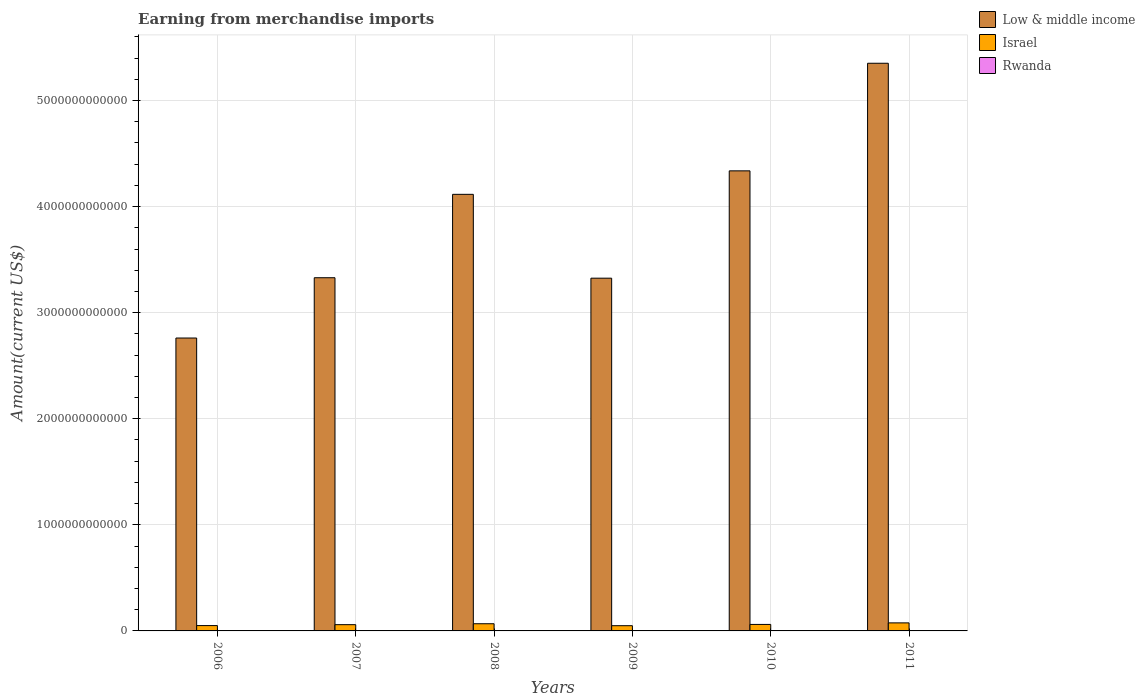How many different coloured bars are there?
Offer a very short reply. 3. How many groups of bars are there?
Ensure brevity in your answer.  6. Are the number of bars on each tick of the X-axis equal?
Offer a terse response. Yes. How many bars are there on the 2nd tick from the left?
Give a very brief answer. 3. What is the label of the 6th group of bars from the left?
Give a very brief answer. 2011. In how many cases, is the number of bars for a given year not equal to the number of legend labels?
Ensure brevity in your answer.  0. What is the amount earned from merchandise imports in Low & middle income in 2009?
Offer a terse response. 3.33e+12. Across all years, what is the maximum amount earned from merchandise imports in Low & middle income?
Your answer should be very brief. 5.35e+12. Across all years, what is the minimum amount earned from merchandise imports in Low & middle income?
Keep it short and to the point. 2.76e+12. In which year was the amount earned from merchandise imports in Rwanda minimum?
Make the answer very short. 2006. What is the total amount earned from merchandise imports in Low & middle income in the graph?
Your response must be concise. 2.32e+13. What is the difference between the amount earned from merchandise imports in Israel in 2006 and that in 2010?
Your answer should be compact. -1.09e+1. What is the difference between the amount earned from merchandise imports in Rwanda in 2008 and the amount earned from merchandise imports in Low & middle income in 2010?
Provide a succinct answer. -4.34e+12. What is the average amount earned from merchandise imports in Low & middle income per year?
Keep it short and to the point. 3.87e+12. In the year 2006, what is the difference between the amount earned from merchandise imports in Low & middle income and amount earned from merchandise imports in Israel?
Keep it short and to the point. 2.71e+12. In how many years, is the amount earned from merchandise imports in Israel greater than 5400000000000 US$?
Your answer should be compact. 0. What is the ratio of the amount earned from merchandise imports in Rwanda in 2008 to that in 2010?
Keep it short and to the point. 0.82. Is the amount earned from merchandise imports in Low & middle income in 2006 less than that in 2008?
Your answer should be compact. Yes. What is the difference between the highest and the second highest amount earned from merchandise imports in Israel?
Your answer should be compact. 8.17e+09. What is the difference between the highest and the lowest amount earned from merchandise imports in Israel?
Your answer should be very brief. 2.66e+1. What does the 1st bar from the right in 2006 represents?
Your answer should be compact. Rwanda. Is it the case that in every year, the sum of the amount earned from merchandise imports in Low & middle income and amount earned from merchandise imports in Israel is greater than the amount earned from merchandise imports in Rwanda?
Offer a very short reply. Yes. How many years are there in the graph?
Offer a very short reply. 6. What is the difference between two consecutive major ticks on the Y-axis?
Your answer should be very brief. 1.00e+12. Does the graph contain any zero values?
Keep it short and to the point. No. Does the graph contain grids?
Give a very brief answer. Yes. How many legend labels are there?
Make the answer very short. 3. What is the title of the graph?
Offer a very short reply. Earning from merchandise imports. What is the label or title of the Y-axis?
Provide a succinct answer. Amount(current US$). What is the Amount(current US$) of Low & middle income in 2006?
Give a very brief answer. 2.76e+12. What is the Amount(current US$) of Israel in 2006?
Your answer should be compact. 5.03e+1. What is the Amount(current US$) of Rwanda in 2006?
Your answer should be very brief. 5.91e+08. What is the Amount(current US$) of Low & middle income in 2007?
Make the answer very short. 3.33e+12. What is the Amount(current US$) in Israel in 2007?
Give a very brief answer. 5.90e+1. What is the Amount(current US$) in Rwanda in 2007?
Your response must be concise. 7.71e+08. What is the Amount(current US$) in Low & middle income in 2008?
Offer a very short reply. 4.12e+12. What is the Amount(current US$) in Israel in 2008?
Your answer should be compact. 6.77e+1. What is the Amount(current US$) of Rwanda in 2008?
Provide a short and direct response. 1.17e+09. What is the Amount(current US$) of Low & middle income in 2009?
Offer a very short reply. 3.33e+12. What is the Amount(current US$) in Israel in 2009?
Provide a short and direct response. 4.93e+1. What is the Amount(current US$) of Rwanda in 2009?
Your answer should be compact. 1.31e+09. What is the Amount(current US$) of Low & middle income in 2010?
Your response must be concise. 4.34e+12. What is the Amount(current US$) in Israel in 2010?
Offer a very short reply. 6.12e+1. What is the Amount(current US$) in Rwanda in 2010?
Provide a succinct answer. 1.43e+09. What is the Amount(current US$) of Low & middle income in 2011?
Make the answer very short. 5.35e+12. What is the Amount(current US$) of Israel in 2011?
Provide a short and direct response. 7.58e+1. What is the Amount(current US$) of Rwanda in 2011?
Provide a short and direct response. 2.04e+09. Across all years, what is the maximum Amount(current US$) in Low & middle income?
Provide a succinct answer. 5.35e+12. Across all years, what is the maximum Amount(current US$) of Israel?
Offer a very short reply. 7.58e+1. Across all years, what is the maximum Amount(current US$) of Rwanda?
Your response must be concise. 2.04e+09. Across all years, what is the minimum Amount(current US$) of Low & middle income?
Give a very brief answer. 2.76e+12. Across all years, what is the minimum Amount(current US$) of Israel?
Make the answer very short. 4.93e+1. Across all years, what is the minimum Amount(current US$) of Rwanda?
Ensure brevity in your answer.  5.91e+08. What is the total Amount(current US$) in Low & middle income in the graph?
Make the answer very short. 2.32e+13. What is the total Amount(current US$) of Israel in the graph?
Your answer should be compact. 3.63e+11. What is the total Amount(current US$) in Rwanda in the graph?
Keep it short and to the point. 7.31e+09. What is the difference between the Amount(current US$) of Low & middle income in 2006 and that in 2007?
Your answer should be compact. -5.68e+11. What is the difference between the Amount(current US$) of Israel in 2006 and that in 2007?
Keep it short and to the point. -8.70e+09. What is the difference between the Amount(current US$) of Rwanda in 2006 and that in 2007?
Ensure brevity in your answer.  -1.79e+08. What is the difference between the Amount(current US$) in Low & middle income in 2006 and that in 2008?
Give a very brief answer. -1.35e+12. What is the difference between the Amount(current US$) of Israel in 2006 and that in 2008?
Your answer should be compact. -1.73e+1. What is the difference between the Amount(current US$) in Rwanda in 2006 and that in 2008?
Offer a terse response. -5.83e+08. What is the difference between the Amount(current US$) of Low & middle income in 2006 and that in 2009?
Keep it short and to the point. -5.64e+11. What is the difference between the Amount(current US$) of Israel in 2006 and that in 2009?
Ensure brevity in your answer.  1.06e+09. What is the difference between the Amount(current US$) in Rwanda in 2006 and that in 2009?
Make the answer very short. -7.17e+08. What is the difference between the Amount(current US$) in Low & middle income in 2006 and that in 2010?
Your response must be concise. -1.58e+12. What is the difference between the Amount(current US$) of Israel in 2006 and that in 2010?
Keep it short and to the point. -1.09e+1. What is the difference between the Amount(current US$) in Rwanda in 2006 and that in 2010?
Keep it short and to the point. -8.40e+08. What is the difference between the Amount(current US$) of Low & middle income in 2006 and that in 2011?
Your answer should be compact. -2.59e+12. What is the difference between the Amount(current US$) of Israel in 2006 and that in 2011?
Ensure brevity in your answer.  -2.55e+1. What is the difference between the Amount(current US$) of Rwanda in 2006 and that in 2011?
Offer a terse response. -1.45e+09. What is the difference between the Amount(current US$) in Low & middle income in 2007 and that in 2008?
Keep it short and to the point. -7.86e+11. What is the difference between the Amount(current US$) of Israel in 2007 and that in 2008?
Offer a very short reply. -8.62e+09. What is the difference between the Amount(current US$) in Rwanda in 2007 and that in 2008?
Your answer should be compact. -4.03e+08. What is the difference between the Amount(current US$) of Low & middle income in 2007 and that in 2009?
Ensure brevity in your answer.  4.29e+09. What is the difference between the Amount(current US$) in Israel in 2007 and that in 2009?
Provide a succinct answer. 9.76e+09. What is the difference between the Amount(current US$) in Rwanda in 2007 and that in 2009?
Offer a terse response. -5.38e+08. What is the difference between the Amount(current US$) in Low & middle income in 2007 and that in 2010?
Your response must be concise. -1.01e+12. What is the difference between the Amount(current US$) of Israel in 2007 and that in 2010?
Your answer should be compact. -2.17e+09. What is the difference between the Amount(current US$) in Rwanda in 2007 and that in 2010?
Offer a terse response. -6.60e+08. What is the difference between the Amount(current US$) in Low & middle income in 2007 and that in 2011?
Make the answer very short. -2.02e+12. What is the difference between the Amount(current US$) in Israel in 2007 and that in 2011?
Provide a short and direct response. -1.68e+1. What is the difference between the Amount(current US$) of Rwanda in 2007 and that in 2011?
Your response must be concise. -1.27e+09. What is the difference between the Amount(current US$) of Low & middle income in 2008 and that in 2009?
Provide a short and direct response. 7.90e+11. What is the difference between the Amount(current US$) of Israel in 2008 and that in 2009?
Ensure brevity in your answer.  1.84e+1. What is the difference between the Amount(current US$) of Rwanda in 2008 and that in 2009?
Offer a terse response. -1.34e+08. What is the difference between the Amount(current US$) in Low & middle income in 2008 and that in 2010?
Make the answer very short. -2.21e+11. What is the difference between the Amount(current US$) of Israel in 2008 and that in 2010?
Keep it short and to the point. 6.45e+09. What is the difference between the Amount(current US$) of Rwanda in 2008 and that in 2010?
Keep it short and to the point. -2.57e+08. What is the difference between the Amount(current US$) of Low & middle income in 2008 and that in 2011?
Keep it short and to the point. -1.24e+12. What is the difference between the Amount(current US$) in Israel in 2008 and that in 2011?
Give a very brief answer. -8.17e+09. What is the difference between the Amount(current US$) of Rwanda in 2008 and that in 2011?
Keep it short and to the point. -8.65e+08. What is the difference between the Amount(current US$) in Low & middle income in 2009 and that in 2010?
Your answer should be compact. -1.01e+12. What is the difference between the Amount(current US$) in Israel in 2009 and that in 2010?
Provide a short and direct response. -1.19e+1. What is the difference between the Amount(current US$) of Rwanda in 2009 and that in 2010?
Ensure brevity in your answer.  -1.23e+08. What is the difference between the Amount(current US$) of Low & middle income in 2009 and that in 2011?
Give a very brief answer. -2.03e+12. What is the difference between the Amount(current US$) in Israel in 2009 and that in 2011?
Your answer should be compact. -2.66e+1. What is the difference between the Amount(current US$) in Rwanda in 2009 and that in 2011?
Your response must be concise. -7.31e+08. What is the difference between the Amount(current US$) of Low & middle income in 2010 and that in 2011?
Ensure brevity in your answer.  -1.01e+12. What is the difference between the Amount(current US$) in Israel in 2010 and that in 2011?
Provide a short and direct response. -1.46e+1. What is the difference between the Amount(current US$) of Rwanda in 2010 and that in 2011?
Your response must be concise. -6.08e+08. What is the difference between the Amount(current US$) of Low & middle income in 2006 and the Amount(current US$) of Israel in 2007?
Offer a terse response. 2.70e+12. What is the difference between the Amount(current US$) of Low & middle income in 2006 and the Amount(current US$) of Rwanda in 2007?
Offer a very short reply. 2.76e+12. What is the difference between the Amount(current US$) in Israel in 2006 and the Amount(current US$) in Rwanda in 2007?
Keep it short and to the point. 4.96e+1. What is the difference between the Amount(current US$) in Low & middle income in 2006 and the Amount(current US$) in Israel in 2008?
Give a very brief answer. 2.69e+12. What is the difference between the Amount(current US$) of Low & middle income in 2006 and the Amount(current US$) of Rwanda in 2008?
Offer a terse response. 2.76e+12. What is the difference between the Amount(current US$) of Israel in 2006 and the Amount(current US$) of Rwanda in 2008?
Give a very brief answer. 4.92e+1. What is the difference between the Amount(current US$) in Low & middle income in 2006 and the Amount(current US$) in Israel in 2009?
Make the answer very short. 2.71e+12. What is the difference between the Amount(current US$) in Low & middle income in 2006 and the Amount(current US$) in Rwanda in 2009?
Your answer should be compact. 2.76e+12. What is the difference between the Amount(current US$) in Israel in 2006 and the Amount(current US$) in Rwanda in 2009?
Make the answer very short. 4.90e+1. What is the difference between the Amount(current US$) in Low & middle income in 2006 and the Amount(current US$) in Israel in 2010?
Offer a very short reply. 2.70e+12. What is the difference between the Amount(current US$) in Low & middle income in 2006 and the Amount(current US$) in Rwanda in 2010?
Provide a short and direct response. 2.76e+12. What is the difference between the Amount(current US$) of Israel in 2006 and the Amount(current US$) of Rwanda in 2010?
Offer a terse response. 4.89e+1. What is the difference between the Amount(current US$) of Low & middle income in 2006 and the Amount(current US$) of Israel in 2011?
Your response must be concise. 2.69e+12. What is the difference between the Amount(current US$) in Low & middle income in 2006 and the Amount(current US$) in Rwanda in 2011?
Provide a succinct answer. 2.76e+12. What is the difference between the Amount(current US$) of Israel in 2006 and the Amount(current US$) of Rwanda in 2011?
Your response must be concise. 4.83e+1. What is the difference between the Amount(current US$) in Low & middle income in 2007 and the Amount(current US$) in Israel in 2008?
Offer a terse response. 3.26e+12. What is the difference between the Amount(current US$) of Low & middle income in 2007 and the Amount(current US$) of Rwanda in 2008?
Your response must be concise. 3.33e+12. What is the difference between the Amount(current US$) of Israel in 2007 and the Amount(current US$) of Rwanda in 2008?
Your answer should be very brief. 5.79e+1. What is the difference between the Amount(current US$) in Low & middle income in 2007 and the Amount(current US$) in Israel in 2009?
Give a very brief answer. 3.28e+12. What is the difference between the Amount(current US$) of Low & middle income in 2007 and the Amount(current US$) of Rwanda in 2009?
Ensure brevity in your answer.  3.33e+12. What is the difference between the Amount(current US$) of Israel in 2007 and the Amount(current US$) of Rwanda in 2009?
Keep it short and to the point. 5.77e+1. What is the difference between the Amount(current US$) of Low & middle income in 2007 and the Amount(current US$) of Israel in 2010?
Provide a succinct answer. 3.27e+12. What is the difference between the Amount(current US$) in Low & middle income in 2007 and the Amount(current US$) in Rwanda in 2010?
Ensure brevity in your answer.  3.33e+12. What is the difference between the Amount(current US$) of Israel in 2007 and the Amount(current US$) of Rwanda in 2010?
Your answer should be compact. 5.76e+1. What is the difference between the Amount(current US$) in Low & middle income in 2007 and the Amount(current US$) in Israel in 2011?
Provide a succinct answer. 3.25e+12. What is the difference between the Amount(current US$) of Low & middle income in 2007 and the Amount(current US$) of Rwanda in 2011?
Offer a very short reply. 3.33e+12. What is the difference between the Amount(current US$) in Israel in 2007 and the Amount(current US$) in Rwanda in 2011?
Your answer should be compact. 5.70e+1. What is the difference between the Amount(current US$) in Low & middle income in 2008 and the Amount(current US$) in Israel in 2009?
Your answer should be very brief. 4.07e+12. What is the difference between the Amount(current US$) of Low & middle income in 2008 and the Amount(current US$) of Rwanda in 2009?
Your answer should be compact. 4.11e+12. What is the difference between the Amount(current US$) of Israel in 2008 and the Amount(current US$) of Rwanda in 2009?
Offer a terse response. 6.63e+1. What is the difference between the Amount(current US$) of Low & middle income in 2008 and the Amount(current US$) of Israel in 2010?
Give a very brief answer. 4.05e+12. What is the difference between the Amount(current US$) of Low & middle income in 2008 and the Amount(current US$) of Rwanda in 2010?
Provide a short and direct response. 4.11e+12. What is the difference between the Amount(current US$) in Israel in 2008 and the Amount(current US$) in Rwanda in 2010?
Ensure brevity in your answer.  6.62e+1. What is the difference between the Amount(current US$) in Low & middle income in 2008 and the Amount(current US$) in Israel in 2011?
Your answer should be very brief. 4.04e+12. What is the difference between the Amount(current US$) of Low & middle income in 2008 and the Amount(current US$) of Rwanda in 2011?
Your answer should be very brief. 4.11e+12. What is the difference between the Amount(current US$) in Israel in 2008 and the Amount(current US$) in Rwanda in 2011?
Give a very brief answer. 6.56e+1. What is the difference between the Amount(current US$) of Low & middle income in 2009 and the Amount(current US$) of Israel in 2010?
Make the answer very short. 3.26e+12. What is the difference between the Amount(current US$) of Low & middle income in 2009 and the Amount(current US$) of Rwanda in 2010?
Your answer should be compact. 3.32e+12. What is the difference between the Amount(current US$) of Israel in 2009 and the Amount(current US$) of Rwanda in 2010?
Offer a terse response. 4.78e+1. What is the difference between the Amount(current US$) in Low & middle income in 2009 and the Amount(current US$) in Israel in 2011?
Offer a terse response. 3.25e+12. What is the difference between the Amount(current US$) in Low & middle income in 2009 and the Amount(current US$) in Rwanda in 2011?
Ensure brevity in your answer.  3.32e+12. What is the difference between the Amount(current US$) in Israel in 2009 and the Amount(current US$) in Rwanda in 2011?
Provide a short and direct response. 4.72e+1. What is the difference between the Amount(current US$) in Low & middle income in 2010 and the Amount(current US$) in Israel in 2011?
Provide a succinct answer. 4.26e+12. What is the difference between the Amount(current US$) in Low & middle income in 2010 and the Amount(current US$) in Rwanda in 2011?
Ensure brevity in your answer.  4.33e+12. What is the difference between the Amount(current US$) in Israel in 2010 and the Amount(current US$) in Rwanda in 2011?
Your answer should be very brief. 5.92e+1. What is the average Amount(current US$) in Low & middle income per year?
Your response must be concise. 3.87e+12. What is the average Amount(current US$) of Israel per year?
Provide a short and direct response. 6.06e+1. What is the average Amount(current US$) in Rwanda per year?
Your response must be concise. 1.22e+09. In the year 2006, what is the difference between the Amount(current US$) in Low & middle income and Amount(current US$) in Israel?
Provide a succinct answer. 2.71e+12. In the year 2006, what is the difference between the Amount(current US$) of Low & middle income and Amount(current US$) of Rwanda?
Offer a very short reply. 2.76e+12. In the year 2006, what is the difference between the Amount(current US$) of Israel and Amount(current US$) of Rwanda?
Offer a very short reply. 4.97e+1. In the year 2007, what is the difference between the Amount(current US$) in Low & middle income and Amount(current US$) in Israel?
Your answer should be compact. 3.27e+12. In the year 2007, what is the difference between the Amount(current US$) of Low & middle income and Amount(current US$) of Rwanda?
Your response must be concise. 3.33e+12. In the year 2007, what is the difference between the Amount(current US$) in Israel and Amount(current US$) in Rwanda?
Offer a terse response. 5.83e+1. In the year 2008, what is the difference between the Amount(current US$) of Low & middle income and Amount(current US$) of Israel?
Your response must be concise. 4.05e+12. In the year 2008, what is the difference between the Amount(current US$) of Low & middle income and Amount(current US$) of Rwanda?
Ensure brevity in your answer.  4.11e+12. In the year 2008, what is the difference between the Amount(current US$) in Israel and Amount(current US$) in Rwanda?
Your response must be concise. 6.65e+1. In the year 2009, what is the difference between the Amount(current US$) in Low & middle income and Amount(current US$) in Israel?
Make the answer very short. 3.28e+12. In the year 2009, what is the difference between the Amount(current US$) in Low & middle income and Amount(current US$) in Rwanda?
Your answer should be very brief. 3.32e+12. In the year 2009, what is the difference between the Amount(current US$) in Israel and Amount(current US$) in Rwanda?
Your answer should be very brief. 4.80e+1. In the year 2010, what is the difference between the Amount(current US$) in Low & middle income and Amount(current US$) in Israel?
Ensure brevity in your answer.  4.28e+12. In the year 2010, what is the difference between the Amount(current US$) of Low & middle income and Amount(current US$) of Rwanda?
Give a very brief answer. 4.34e+12. In the year 2010, what is the difference between the Amount(current US$) in Israel and Amount(current US$) in Rwanda?
Make the answer very short. 5.98e+1. In the year 2011, what is the difference between the Amount(current US$) of Low & middle income and Amount(current US$) of Israel?
Offer a very short reply. 5.28e+12. In the year 2011, what is the difference between the Amount(current US$) in Low & middle income and Amount(current US$) in Rwanda?
Your response must be concise. 5.35e+12. In the year 2011, what is the difference between the Amount(current US$) in Israel and Amount(current US$) in Rwanda?
Your answer should be compact. 7.38e+1. What is the ratio of the Amount(current US$) of Low & middle income in 2006 to that in 2007?
Provide a short and direct response. 0.83. What is the ratio of the Amount(current US$) in Israel in 2006 to that in 2007?
Provide a succinct answer. 0.85. What is the ratio of the Amount(current US$) in Rwanda in 2006 to that in 2007?
Offer a terse response. 0.77. What is the ratio of the Amount(current US$) in Low & middle income in 2006 to that in 2008?
Keep it short and to the point. 0.67. What is the ratio of the Amount(current US$) in Israel in 2006 to that in 2008?
Provide a short and direct response. 0.74. What is the ratio of the Amount(current US$) of Rwanda in 2006 to that in 2008?
Your answer should be compact. 0.5. What is the ratio of the Amount(current US$) in Low & middle income in 2006 to that in 2009?
Provide a short and direct response. 0.83. What is the ratio of the Amount(current US$) of Israel in 2006 to that in 2009?
Your answer should be very brief. 1.02. What is the ratio of the Amount(current US$) in Rwanda in 2006 to that in 2009?
Keep it short and to the point. 0.45. What is the ratio of the Amount(current US$) in Low & middle income in 2006 to that in 2010?
Offer a very short reply. 0.64. What is the ratio of the Amount(current US$) in Israel in 2006 to that in 2010?
Provide a short and direct response. 0.82. What is the ratio of the Amount(current US$) in Rwanda in 2006 to that in 2010?
Your answer should be very brief. 0.41. What is the ratio of the Amount(current US$) in Low & middle income in 2006 to that in 2011?
Make the answer very short. 0.52. What is the ratio of the Amount(current US$) in Israel in 2006 to that in 2011?
Provide a succinct answer. 0.66. What is the ratio of the Amount(current US$) of Rwanda in 2006 to that in 2011?
Give a very brief answer. 0.29. What is the ratio of the Amount(current US$) of Low & middle income in 2007 to that in 2008?
Provide a succinct answer. 0.81. What is the ratio of the Amount(current US$) in Israel in 2007 to that in 2008?
Ensure brevity in your answer.  0.87. What is the ratio of the Amount(current US$) of Rwanda in 2007 to that in 2008?
Ensure brevity in your answer.  0.66. What is the ratio of the Amount(current US$) in Israel in 2007 to that in 2009?
Your answer should be very brief. 1.2. What is the ratio of the Amount(current US$) of Rwanda in 2007 to that in 2009?
Provide a succinct answer. 0.59. What is the ratio of the Amount(current US$) of Low & middle income in 2007 to that in 2010?
Offer a terse response. 0.77. What is the ratio of the Amount(current US$) of Israel in 2007 to that in 2010?
Offer a very short reply. 0.96. What is the ratio of the Amount(current US$) in Rwanda in 2007 to that in 2010?
Your answer should be very brief. 0.54. What is the ratio of the Amount(current US$) in Low & middle income in 2007 to that in 2011?
Your answer should be very brief. 0.62. What is the ratio of the Amount(current US$) of Israel in 2007 to that in 2011?
Ensure brevity in your answer.  0.78. What is the ratio of the Amount(current US$) in Rwanda in 2007 to that in 2011?
Your response must be concise. 0.38. What is the ratio of the Amount(current US$) of Low & middle income in 2008 to that in 2009?
Provide a short and direct response. 1.24. What is the ratio of the Amount(current US$) of Israel in 2008 to that in 2009?
Provide a short and direct response. 1.37. What is the ratio of the Amount(current US$) of Rwanda in 2008 to that in 2009?
Give a very brief answer. 0.9. What is the ratio of the Amount(current US$) in Low & middle income in 2008 to that in 2010?
Offer a very short reply. 0.95. What is the ratio of the Amount(current US$) of Israel in 2008 to that in 2010?
Give a very brief answer. 1.11. What is the ratio of the Amount(current US$) of Rwanda in 2008 to that in 2010?
Offer a terse response. 0.82. What is the ratio of the Amount(current US$) of Low & middle income in 2008 to that in 2011?
Offer a terse response. 0.77. What is the ratio of the Amount(current US$) in Israel in 2008 to that in 2011?
Keep it short and to the point. 0.89. What is the ratio of the Amount(current US$) in Rwanda in 2008 to that in 2011?
Ensure brevity in your answer.  0.58. What is the ratio of the Amount(current US$) in Low & middle income in 2009 to that in 2010?
Provide a short and direct response. 0.77. What is the ratio of the Amount(current US$) in Israel in 2009 to that in 2010?
Offer a very short reply. 0.81. What is the ratio of the Amount(current US$) in Rwanda in 2009 to that in 2010?
Offer a terse response. 0.91. What is the ratio of the Amount(current US$) in Low & middle income in 2009 to that in 2011?
Your answer should be compact. 0.62. What is the ratio of the Amount(current US$) in Israel in 2009 to that in 2011?
Provide a succinct answer. 0.65. What is the ratio of the Amount(current US$) of Rwanda in 2009 to that in 2011?
Your answer should be compact. 0.64. What is the ratio of the Amount(current US$) in Low & middle income in 2010 to that in 2011?
Ensure brevity in your answer.  0.81. What is the ratio of the Amount(current US$) in Israel in 2010 to that in 2011?
Provide a succinct answer. 0.81. What is the ratio of the Amount(current US$) of Rwanda in 2010 to that in 2011?
Ensure brevity in your answer.  0.7. What is the difference between the highest and the second highest Amount(current US$) of Low & middle income?
Provide a short and direct response. 1.01e+12. What is the difference between the highest and the second highest Amount(current US$) in Israel?
Offer a terse response. 8.17e+09. What is the difference between the highest and the second highest Amount(current US$) of Rwanda?
Your response must be concise. 6.08e+08. What is the difference between the highest and the lowest Amount(current US$) of Low & middle income?
Keep it short and to the point. 2.59e+12. What is the difference between the highest and the lowest Amount(current US$) in Israel?
Keep it short and to the point. 2.66e+1. What is the difference between the highest and the lowest Amount(current US$) in Rwanda?
Give a very brief answer. 1.45e+09. 